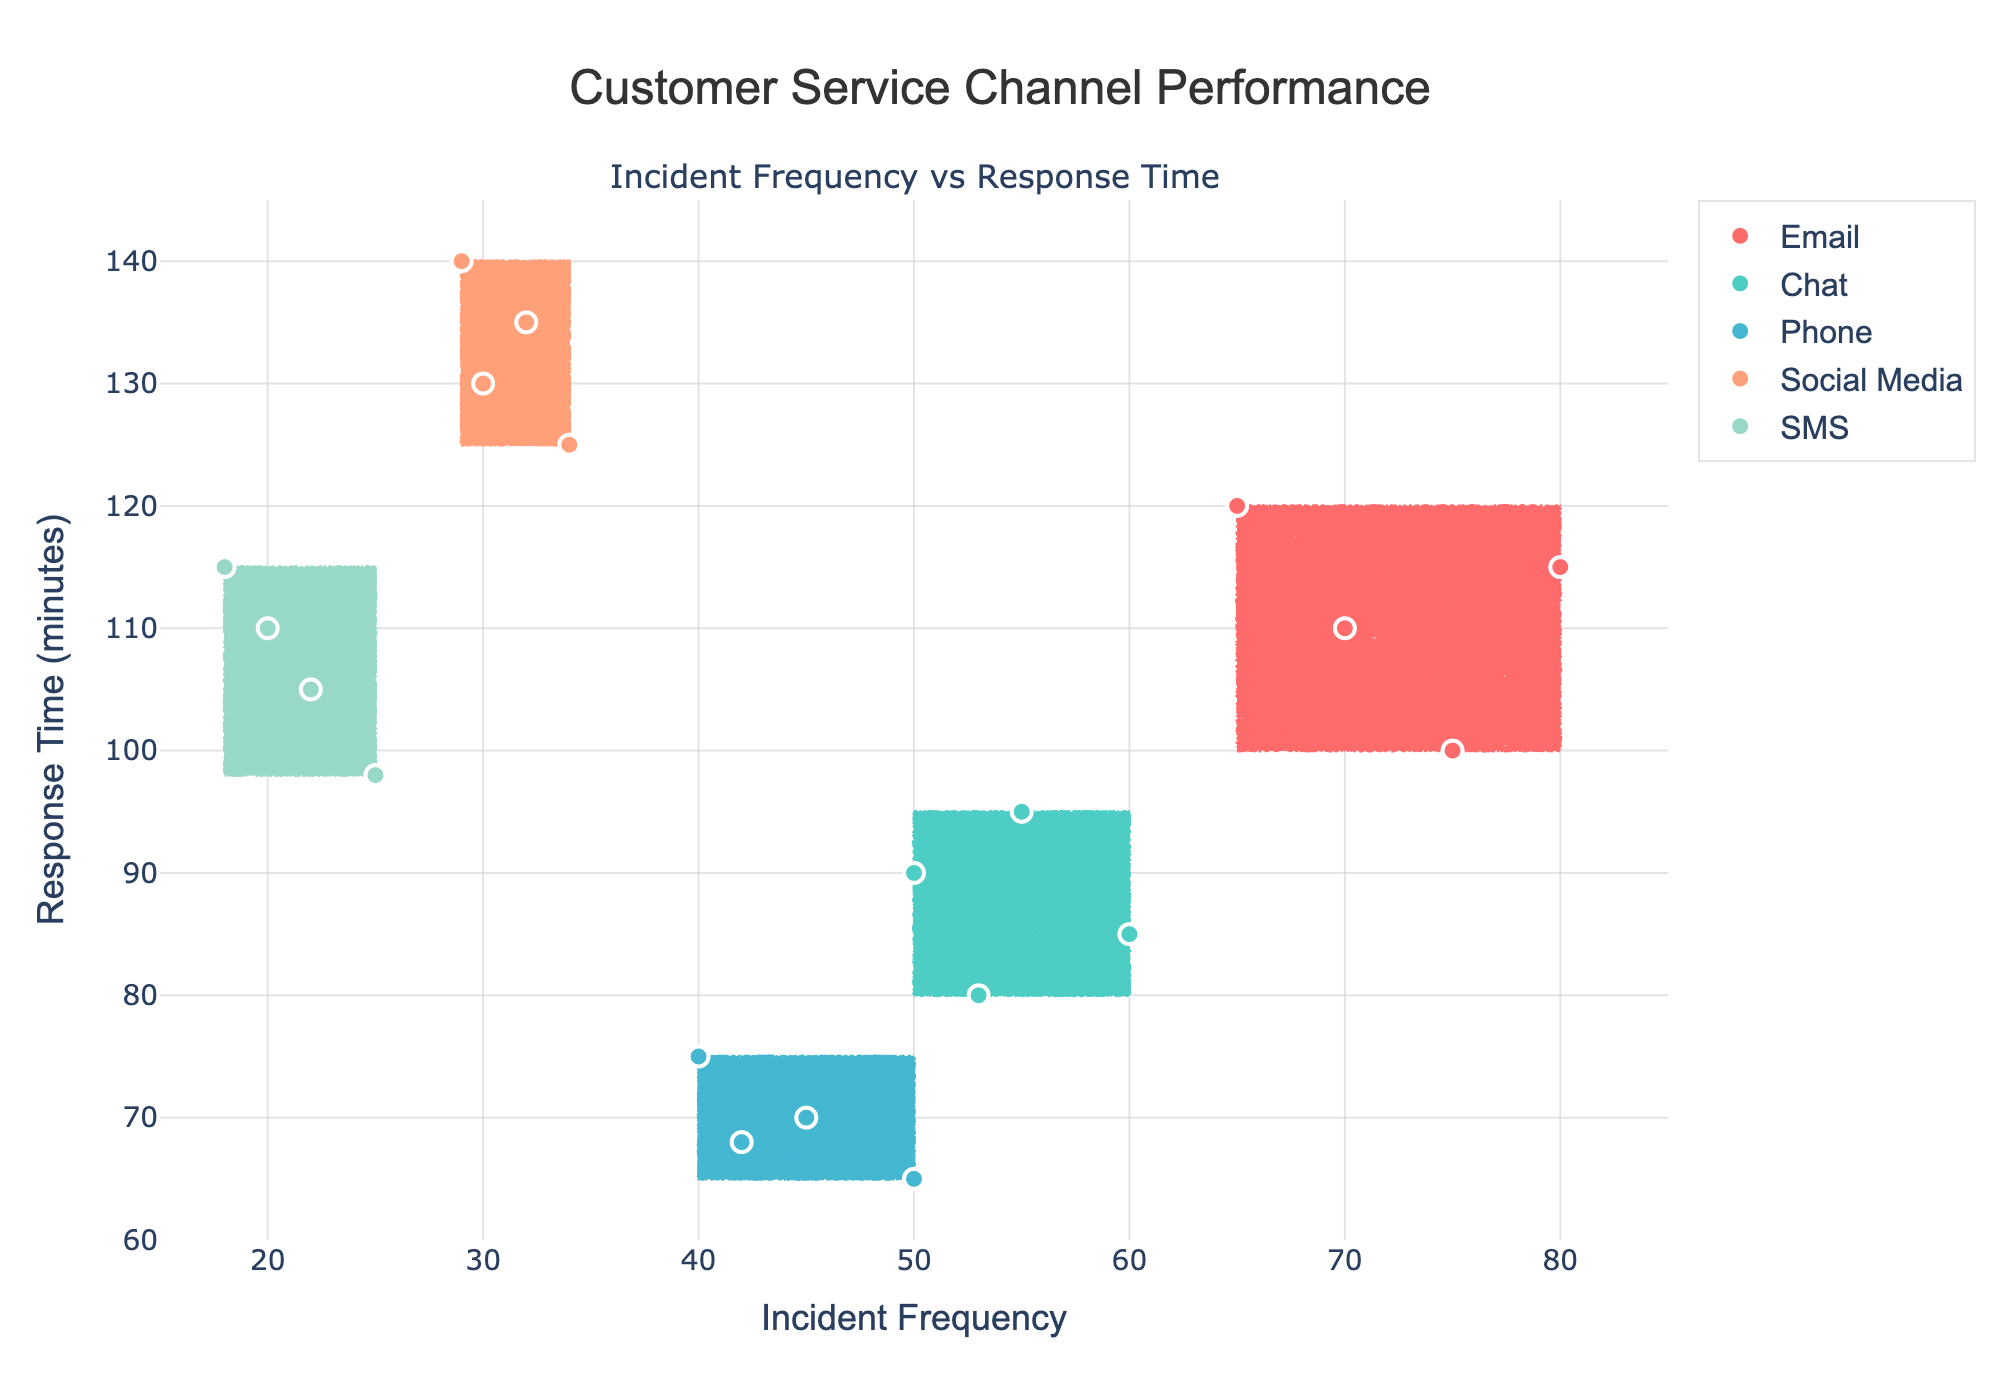What is the title of the figure? The title of the figure is displayed at the top center of the plot. It reads "Customer Service Channel Performance".
Answer: Customer Service Channel Performance What are the ranges of the x-axis and y-axis? The x-axis represents Incident Frequency and ranges from 15 to 85, while the y-axis represents Response Time (minutes) and ranges from 60 to 145. These ranges are evident from the labels and ticks on the axes.
Answer: x-axis: 15 to 85, y-axis: 60 to 145 How many channels are compared in the figure? The figure compares five customer service channels, which are Email, Chat, Phone, Social Media, and SMS. These channels are represented by different colors in the plot legend.
Answer: 5 Which customer service channel has the highest incident frequency? By observing the scatter points, Email has the highest incident frequency as it has points around 65 to 80 on the x-axis.
Answer: Email In what range does the response time for Chat fall? The response points for Chat on the y-axis range from approximately 80 to 95 minutes. These points are indicated by the scatter plot labeled "Chat".
Answer: 80 to 95 minutes Which channel has the lowest response time and what is it? The scatter plot for Phone shows response times ranging from about 65 to 75 minutes, indicating it has the lowest response time among the channels.
Answer: Phone, 65 to 75 minutes Compare the response times of Social Media and SMS. Which one generally has higher response times? Social Media's response times range from 125 to 140 minutes, whereas SMS ranges from 98 to 115 minutes. Comparing these ranges, Social Media generally has higher response times.
Answer: Social Media What is the incident frequency for the single data point from the Email channel that has the lowest response time? The data point from the Email channel with the lowest response time (approximately 100 minutes) has an incident frequency of 75, as evident from the scatter points.
Answer: 75 How does the response time range for Email compare with that of Social Media? Email's response times range from about 100 to 120 minutes, while Social Media's times range from 125 to 140 minutes. Social Media has consistently higher response times compared to Email.
Answer: Social Media has higher response times If you were to describe the performance of the Phone channel in terms of incident frequency and response time, what would you say? The Phone channel has incident frequencies ranging from 40 to 50 and response times between 65 to 75 minutes, indicating it has a lower incident frequency and response time range compared to other channels.
Answer: Lower incident frequency and response time 